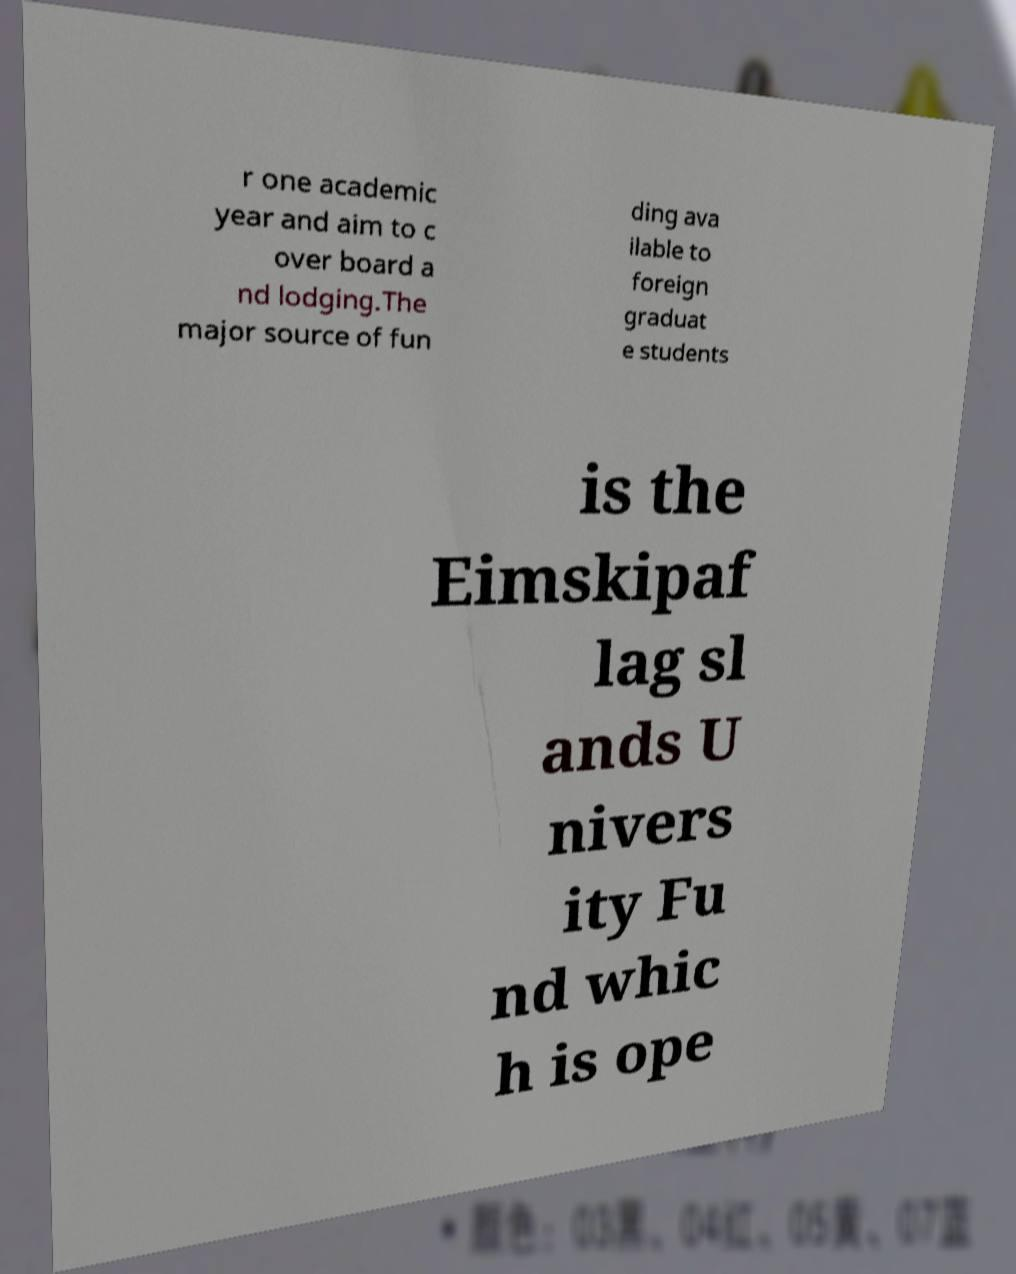There's text embedded in this image that I need extracted. Can you transcribe it verbatim? r one academic year and aim to c over board a nd lodging.The major source of fun ding ava ilable to foreign graduat e students is the Eimskipaf lag sl ands U nivers ity Fu nd whic h is ope 